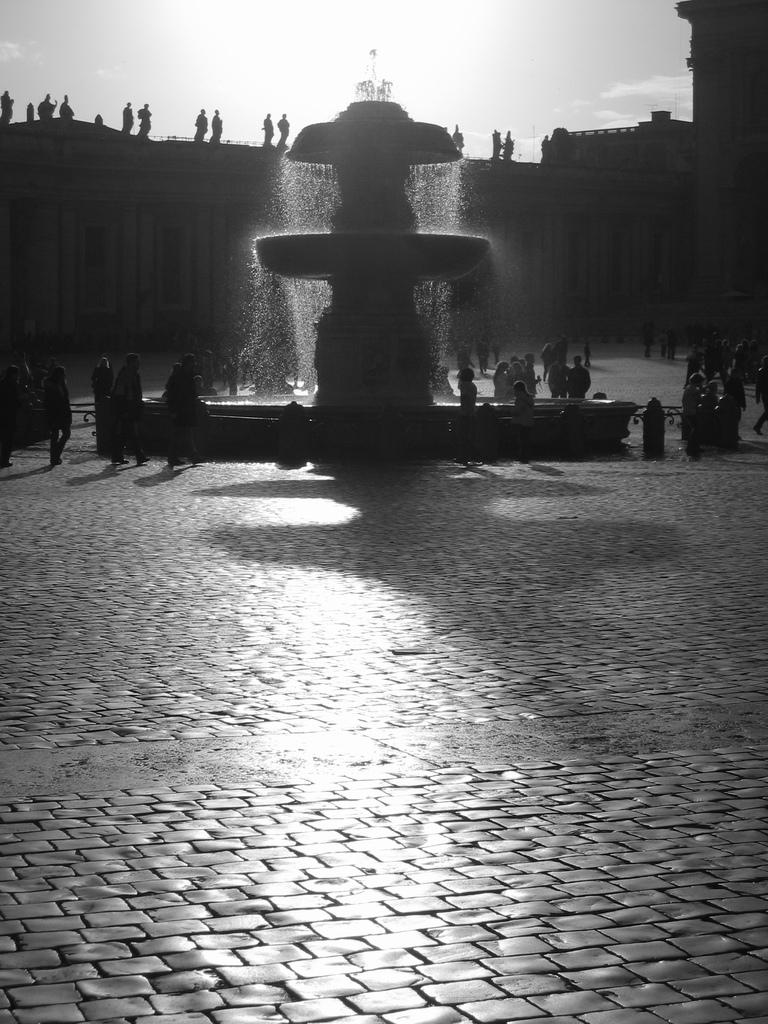What is the main feature in the image? There is a water fountain in the image. What can be seen around the water fountain? There are people standing on the ground in the image. What is visible in the background of the image? There is a building in the background of the image. What is visible at the top of the image? The sky is visible at the top of the image. What type of line is being used to measure the height of the goat in the image? There is no goat present in the image, and therefore no line is being used to measure its height. 